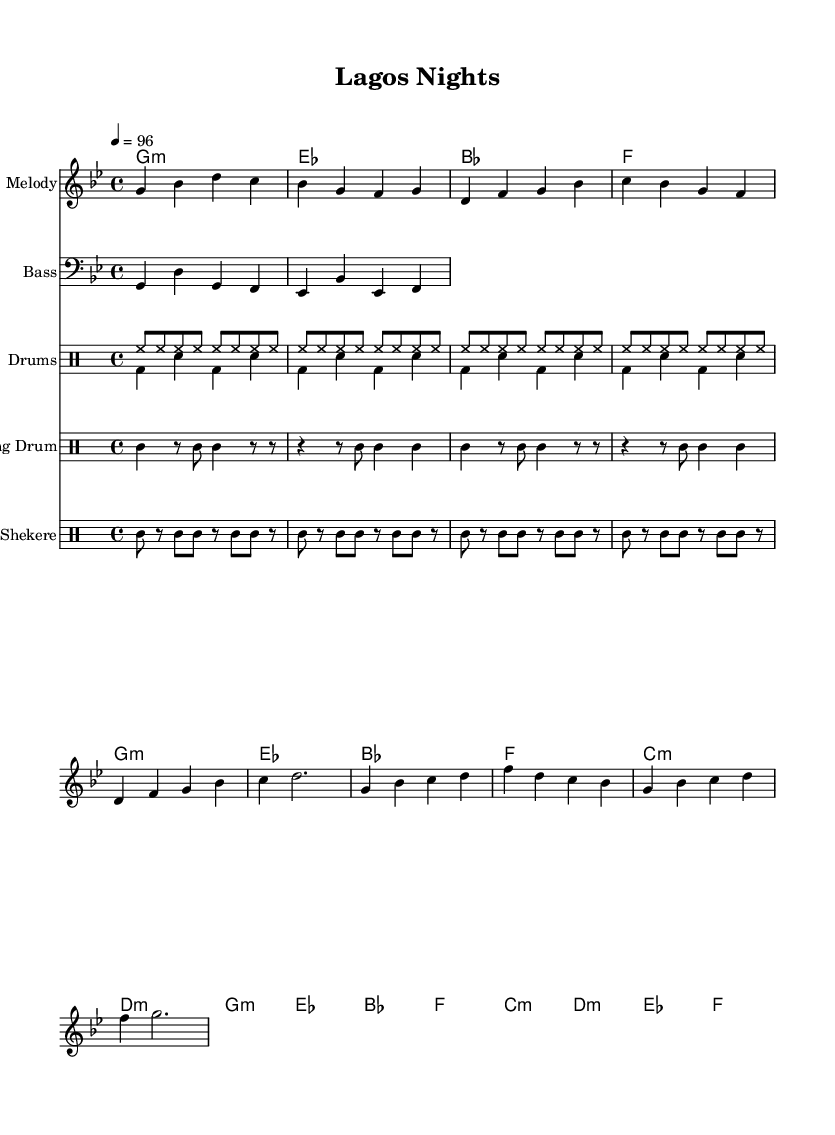What is the key signature of this music? The key signature is G minor, which has two flats (B flat and E flat). This can be determined by checking the key signature indicated on the left side of the staff.
Answer: G minor What is the time signature of this piece? The time signature is 4/4, which means there are four beats in each measure and the quarter note gets one beat. This is indicated at the beginning of the music sheet.
Answer: 4/4 What is the tempo marking for this piece? The tempo marking is 96 beats per minute, which indicates the speed of the music. This can be found next to the tempo indication at the beginning of the piece.
Answer: 96 How many measures are in the verse section? There are 4 measures in the verse section, which can be counted by examining the melody line and identifying the verses. The melody consists of 4 distinct measures for the verse lyrics.
Answer: 4 Which instruments are used in this composition? The instruments used in this composition include melody, bass, drums, talking drum, and shekere. This is shown in the score layout with the different staves for each instrument.
Answer: Melody, bass, drums, talking drum, shekere What type of rhythm is predominantly featured in the drums? The predominant rhythm featured in the drums is a swing rhythm typical in R&B, characterized by a steady hi-hat pattern and bass drum accents. This can be inferred from the drum lines provided in the score.
Answer: Swing rhythm How does the harmony change between the verse and the chorus? The harmony changes in the chorus by introducing more complex chords such as E flat and F, contrasting with the simpler G minor chords in the verse. This can be observed by comparing the harmony sections in both parts.
Answer: It introduces more complex chords 